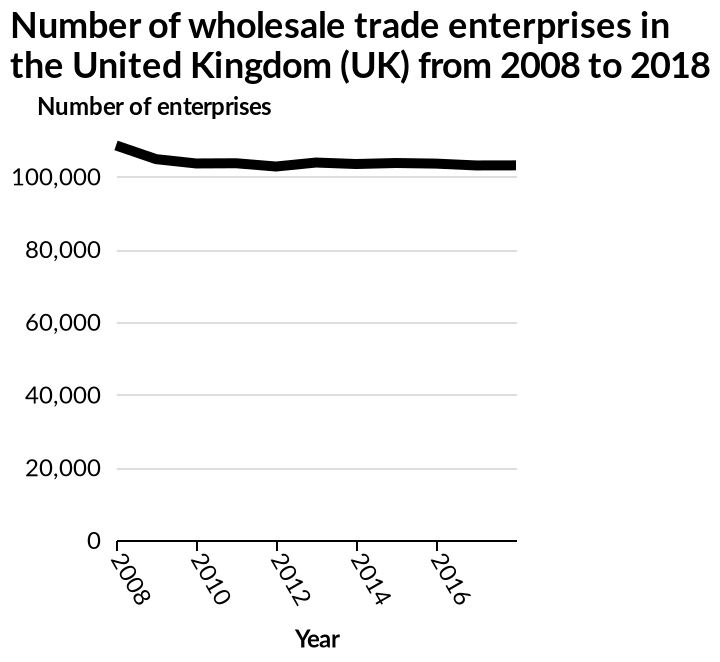<image>
What was the trend in the number of wholesale enterprises in the United Kingdom from 2008 to 2018? The number of wholesale enterprises in the United Kingdom showed a steady decrease from 2008 to 2018. 